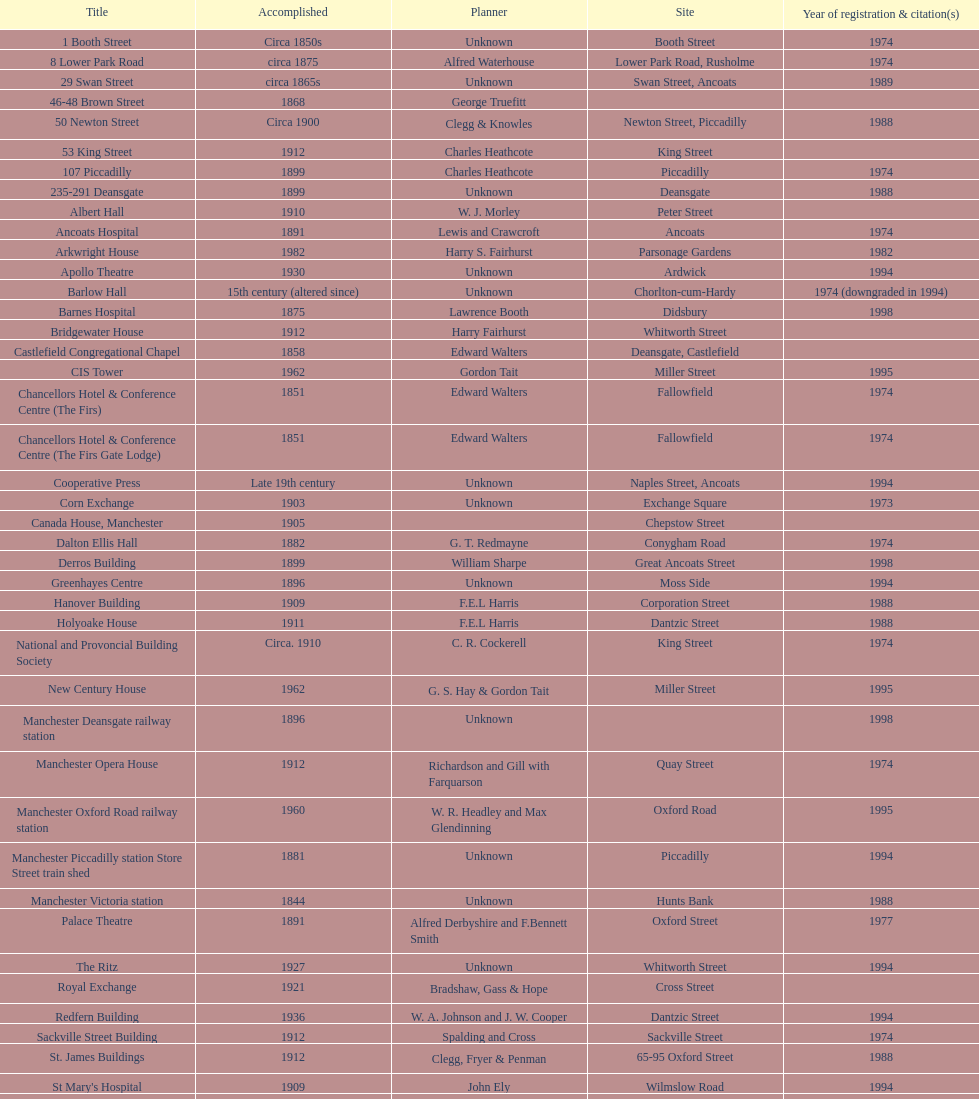How many buildings has the same year of listing as 1974? 15. 